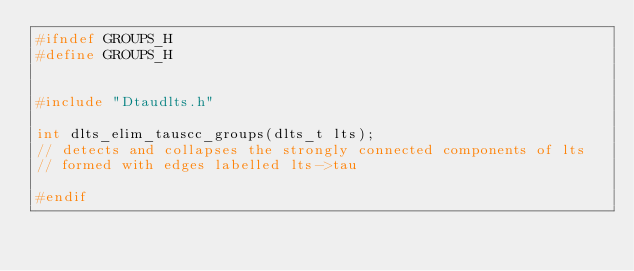<code> <loc_0><loc_0><loc_500><loc_500><_C_>#ifndef GROUPS_H
#define GROUPS_H


#include "Dtaudlts.h"

int dlts_elim_tauscc_groups(dlts_t lts); 
// detects and collapses the strongly connected components of lts
// formed with edges labelled lts->tau

#endif
</code> 